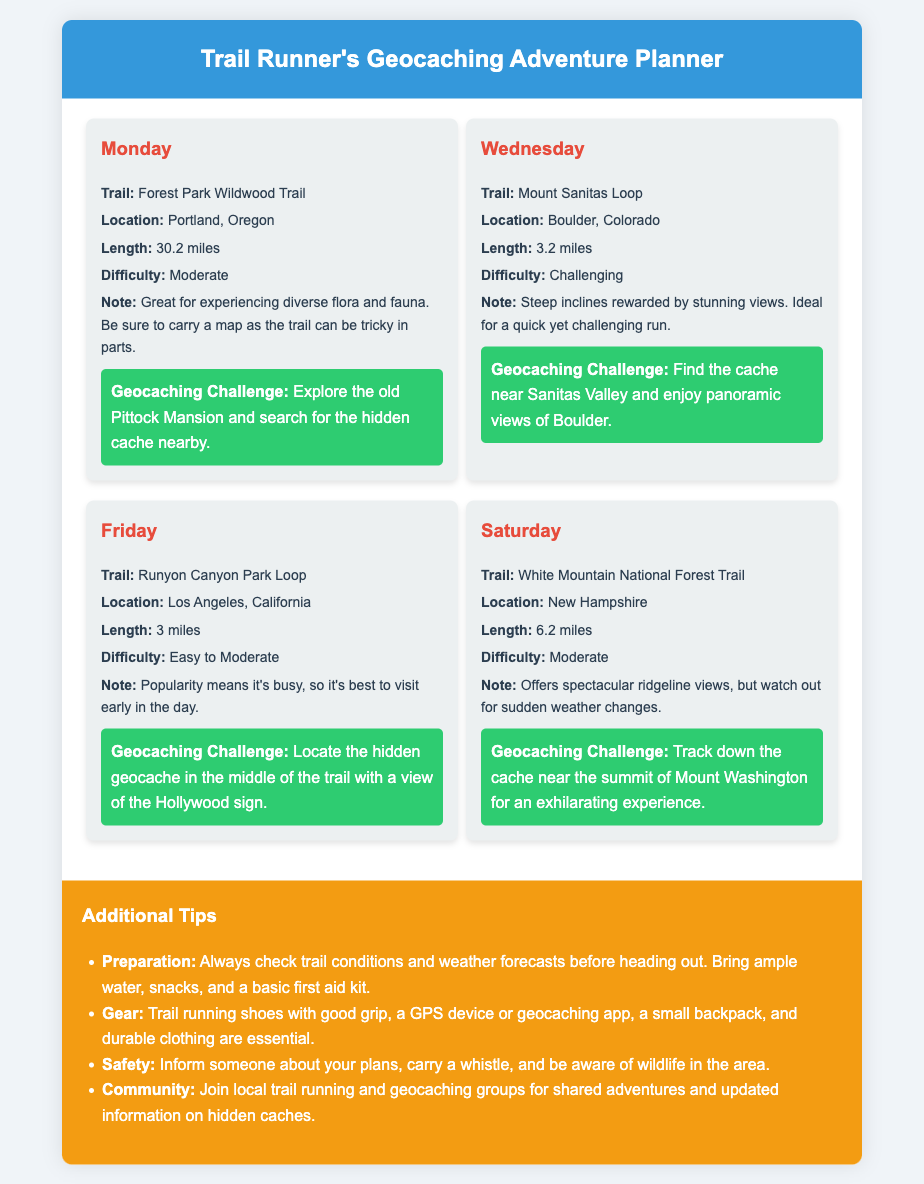What trail is recommended for Monday? The document specifies the trail to be the Forest Park Wildwood Trail for Monday.
Answer: Forest Park Wildwood Trail What is the difficulty level of the Mount Sanitas Loop? The document indicates that the Mount Sanitas Loop has a challenging difficulty level.
Answer: Challenging How long is the Runyon Canyon Park Loop? According to the document, the Runyon Canyon Park Loop has a length of 3 miles.
Answer: 3 miles What cache location is mentioned for Saturday's trail? The document states that the cache for Saturday's trail is located near the summit of Mount Washington.
Answer: Near the summit of Mount Washington Which location features a geocaching challenge involving the Hollywood sign? The geocaching challenge related to the Hollywood sign is specified for Runyon Canyon Park Loop in Los Angeles.
Answer: Runyon Canyon Park Loop What must you carry to navigate the Forest Park Wildwood Trail? The document advises carrying a map for the Forest Park Wildwood Trail due to its tricky nature.
Answer: A map What key item should be included in your gear for geocaching? The document lists a GPS device or geocaching app as essential gear for this activity.
Answer: GPS device or geocaching app What is one reason to visit trails early in the day? The document mentions that the popularity of the Runyon Canyon Park Loop results in busyness, recommending an early visit.
Answer: It's busy What does the document suggest about joining local groups? The document recommends joining local trail running and geocaching groups for shared adventures and updated information on hidden caches.
Answer: Shared adventures and updated information 